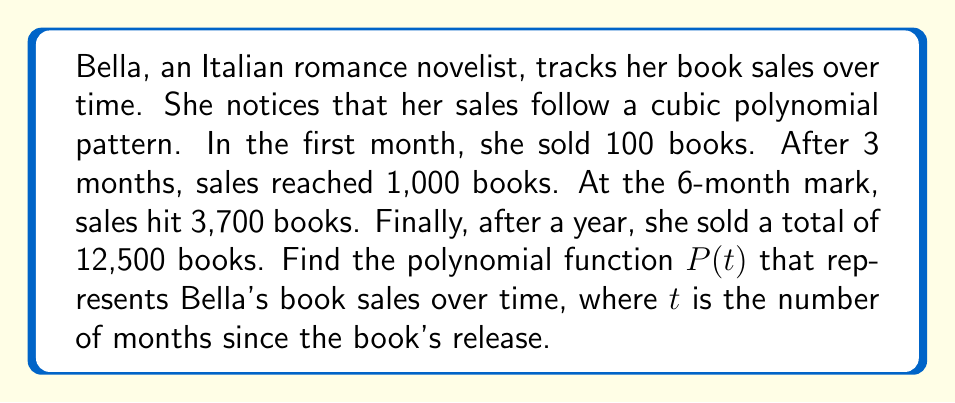What is the answer to this math problem? Let's approach this step-by-step:

1) We're looking for a cubic polynomial of the form:
   $P(t) = at^3 + bt^2 + ct + d$

2) We have four data points:
   $P(0) = 100$
   $P(3) = 1000$
   $P(6) = 3700$
   $P(12) = 12500$

3) Let's set up a system of equations:
   $d = 100$ (when $t = 0$)
   $27a + 9b + 3c + 100 = 1000$
   $216a + 36b + 6c + 100 = 3700$
   $1728a + 144b + 12c + 100 = 12500$

4) Subtracting the first equation from the others:
   $27a + 9b + 3c = 900$
   $216a + 36b + 6c = 3600$
   $1728a + 144b + 12c = 12400$

5) Divide the second equation by 2 and the third by 4:
   $27a + 9b + 3c = 900$
   $108a + 18b + 3c = 1800$
   $432a + 36b + 3c = 3100$

6) Subtracting the first equation from the second and third:
   $81a + 9b = 900$
   $405a + 27b = 2200$

7) Multiply the first equation by 3 and subtract from the second:
   $162a = 500$

8) Solve for $a$:
   $a = \frac{500}{162} \approx 3.0864$

9) Substitute back to find $b$ and $c$:
   $b \approx -23.1481$
   $c \approx 120.0617$

10) Remember that $d = 100$

Therefore, the polynomial function is:
$P(t) \approx 3.0864t^3 - 23.1481t^2 + 120.0617t + 100$
Answer: $P(t) \approx 3.0864t^3 - 23.1481t^2 + 120.0617t + 100$ 